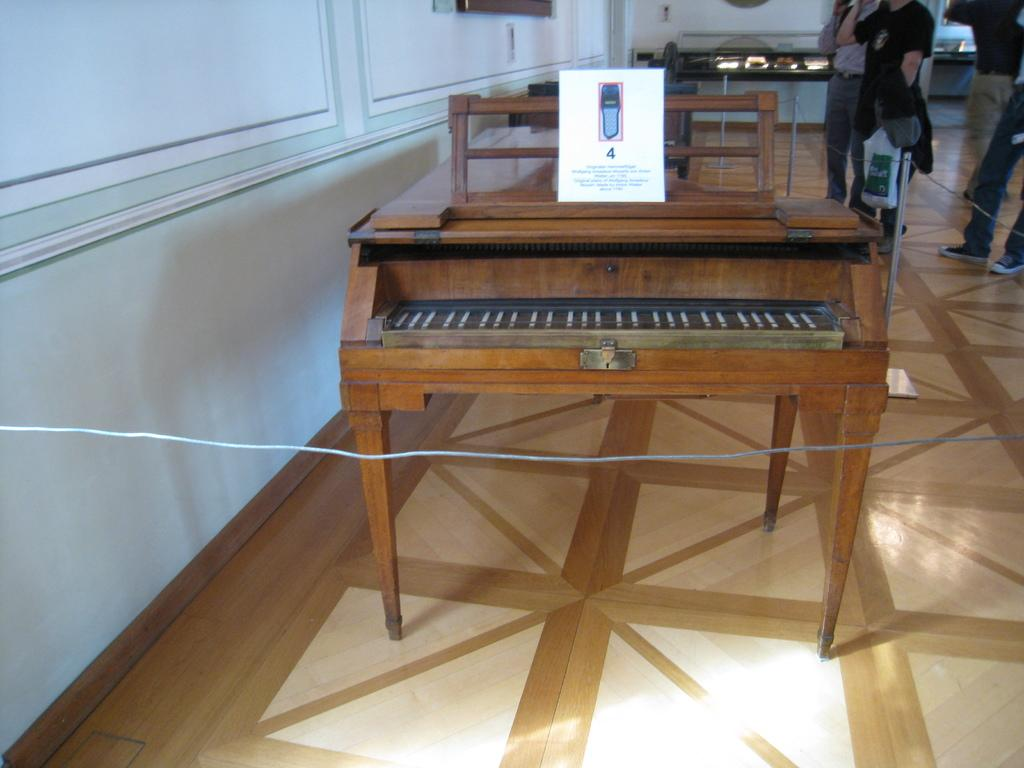What is the main object in the image? There is a piano in the image. What is placed on top of the piano? A board is placed on the piano. Can you describe the people in the background of the image? There are people in the background of the image, but their specific actions or appearances are not mentioned in the facts. What type of floor is visible in the background? The floor in the background appears to be wooden. What can be seen on the wall in the background? There are photo frames on the wall in the background. What other objects or items are visible in the background? There are other objects or items visible in the background, but their specific details are not mentioned in the facts. What type of jelly is being served on the piano? There is no jelly present in the image; the main object in the image is a piano with a board placed on it. 